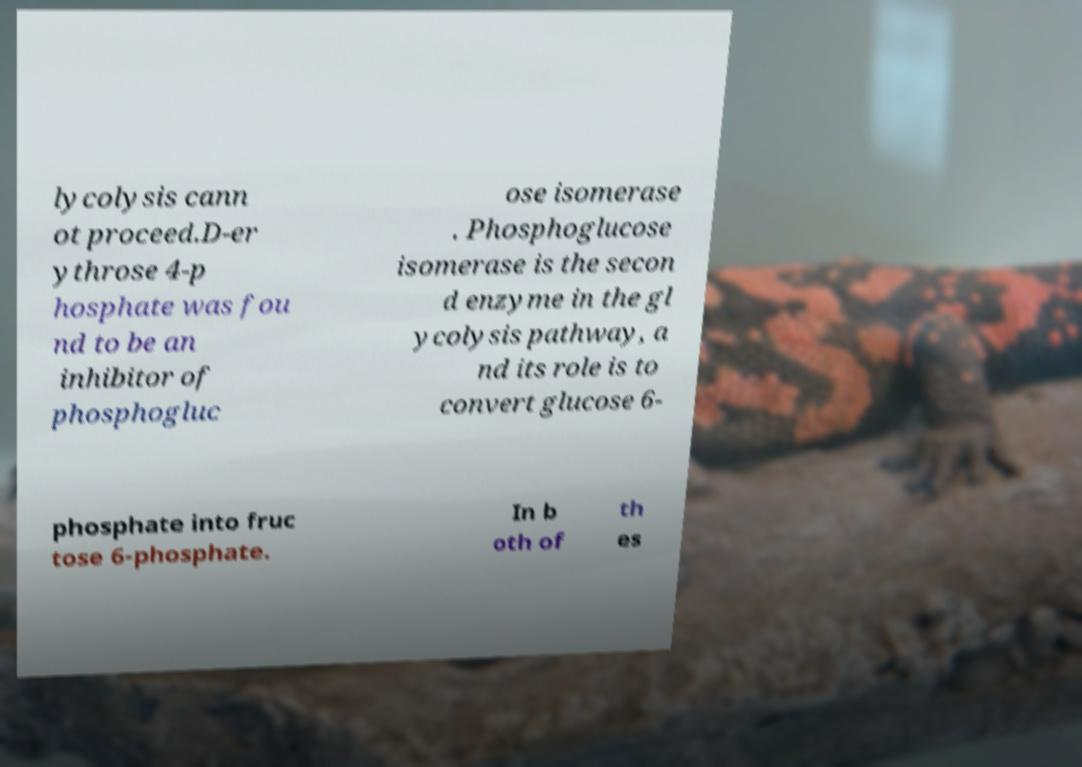Please read and relay the text visible in this image. What does it say? lycolysis cann ot proceed.D-er ythrose 4-p hosphate was fou nd to be an inhibitor of phosphogluc ose isomerase . Phosphoglucose isomerase is the secon d enzyme in the gl ycolysis pathway, a nd its role is to convert glucose 6- phosphate into fruc tose 6-phosphate. In b oth of th es 